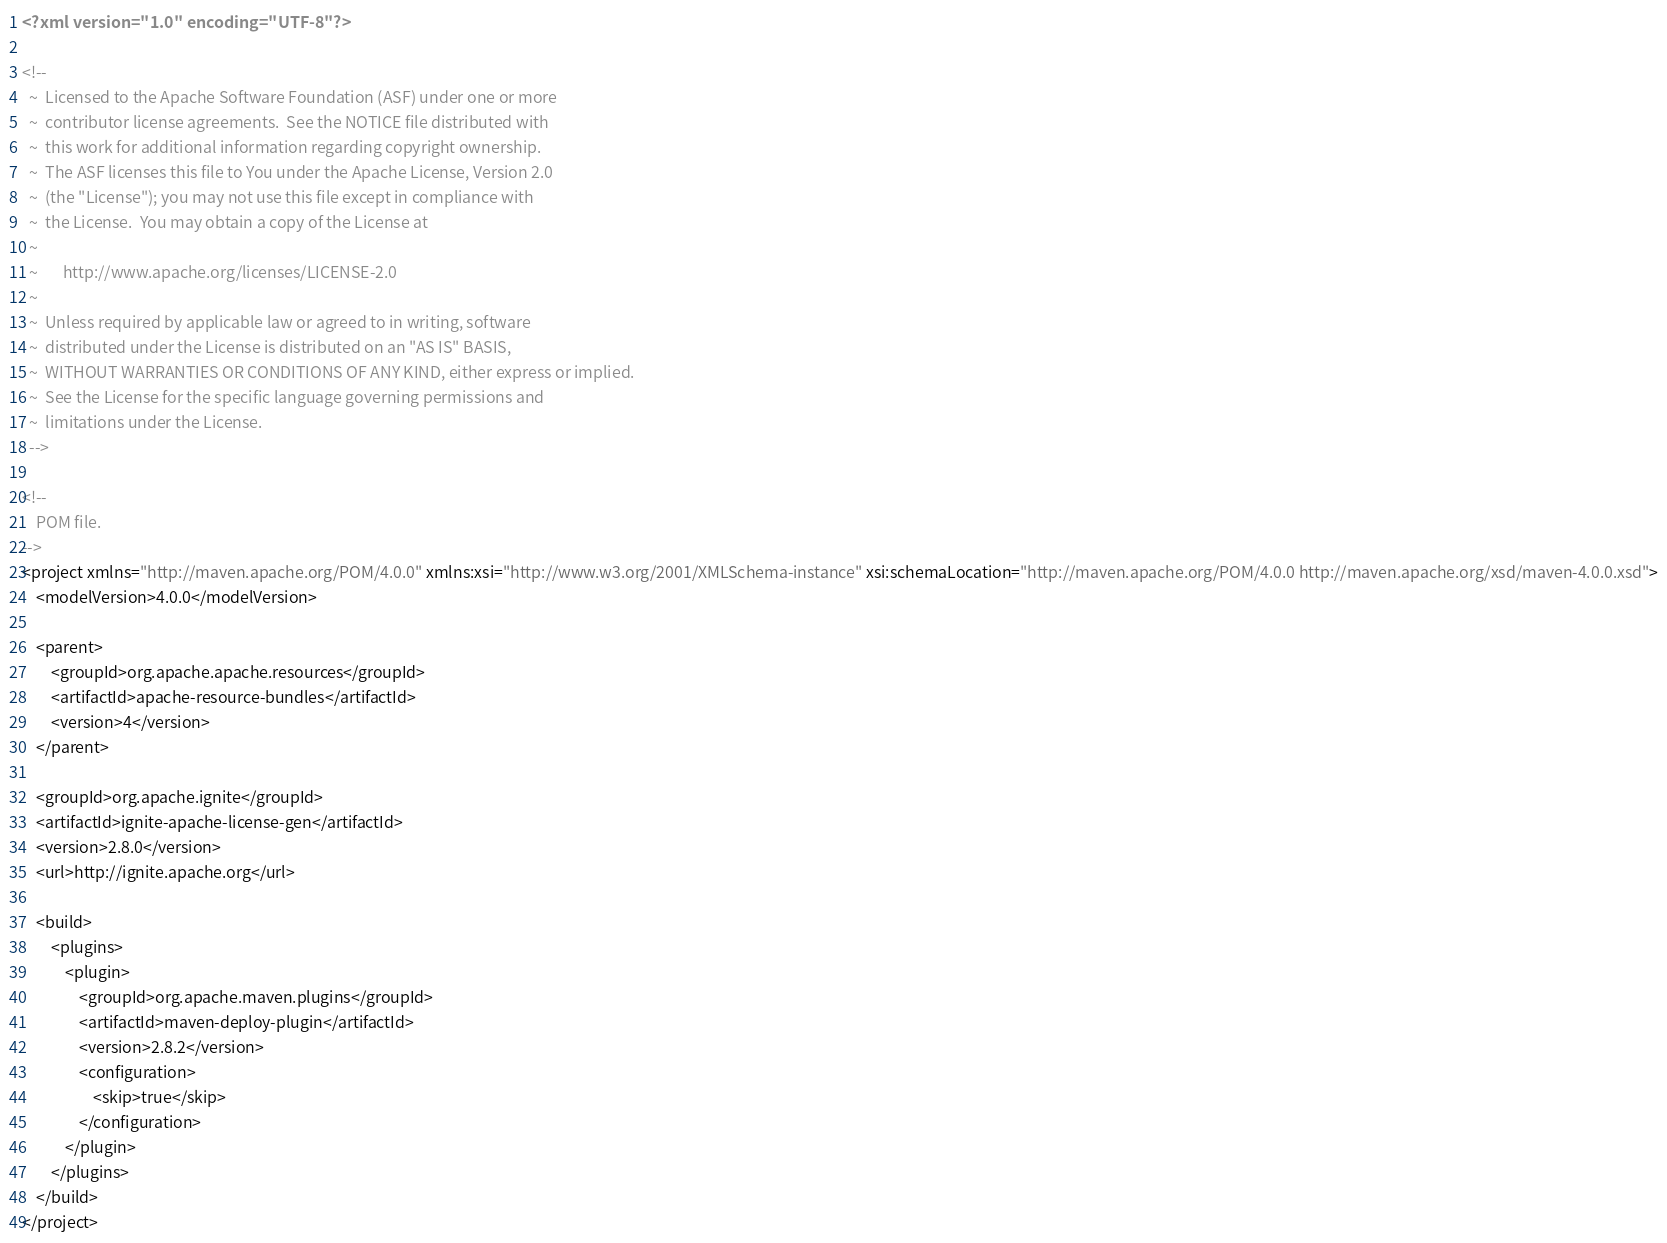Convert code to text. <code><loc_0><loc_0><loc_500><loc_500><_XML_><?xml version="1.0" encoding="UTF-8"?>

<!--
  ~  Licensed to the Apache Software Foundation (ASF) under one or more
  ~  contributor license agreements.  See the NOTICE file distributed with
  ~  this work for additional information regarding copyright ownership.
  ~  The ASF licenses this file to You under the Apache License, Version 2.0
  ~  (the "License"); you may not use this file except in compliance with
  ~  the License.  You may obtain a copy of the License at
  ~
  ~       http://www.apache.org/licenses/LICENSE-2.0
  ~
  ~  Unless required by applicable law or agreed to in writing, software
  ~  distributed under the License is distributed on an "AS IS" BASIS,
  ~  WITHOUT WARRANTIES OR CONDITIONS OF ANY KIND, either express or implied.
  ~  See the License for the specific language governing permissions and
  ~  limitations under the License.
  -->

<!--
    POM file.
-->
<project xmlns="http://maven.apache.org/POM/4.0.0" xmlns:xsi="http://www.w3.org/2001/XMLSchema-instance" xsi:schemaLocation="http://maven.apache.org/POM/4.0.0 http://maven.apache.org/xsd/maven-4.0.0.xsd">
    <modelVersion>4.0.0</modelVersion>

    <parent>
        <groupId>org.apache.apache.resources</groupId>
        <artifactId>apache-resource-bundles</artifactId>
        <version>4</version>
    </parent>

    <groupId>org.apache.ignite</groupId>
    <artifactId>ignite-apache-license-gen</artifactId>
    <version>2.8.0</version>
    <url>http://ignite.apache.org</url>

    <build>
        <plugins>
            <plugin>
                <groupId>org.apache.maven.plugins</groupId>
                <artifactId>maven-deploy-plugin</artifactId>
                <version>2.8.2</version>
                <configuration>
                    <skip>true</skip>
                </configuration>
            </plugin>
        </plugins>
    </build>
</project>
</code> 